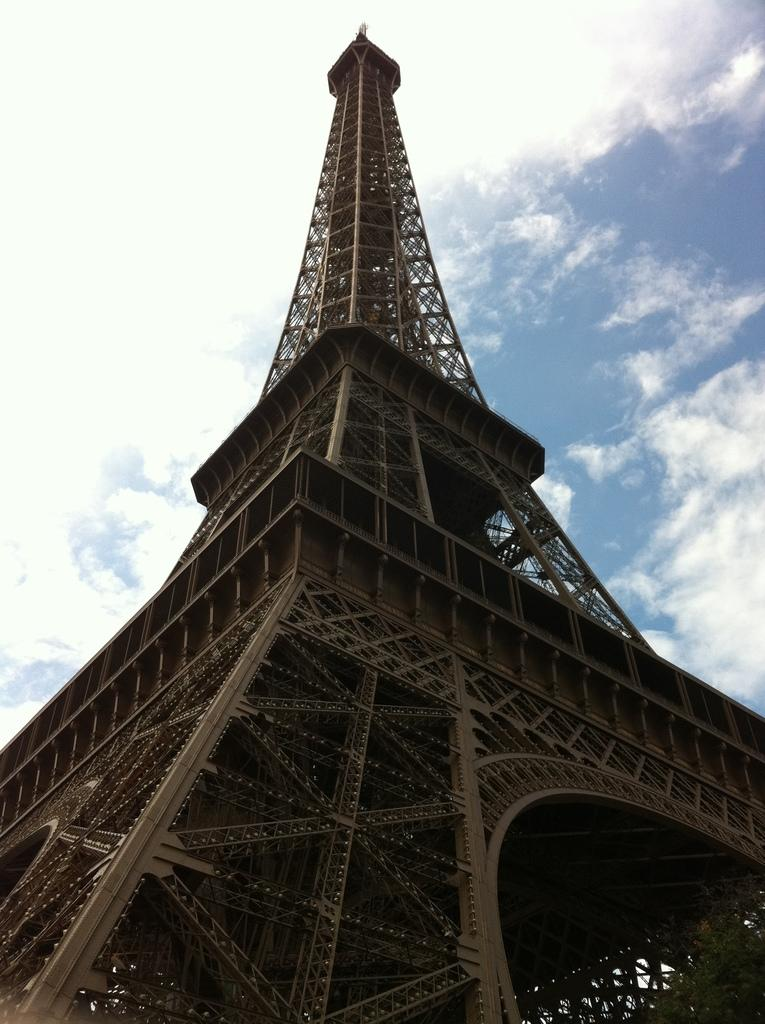What is the main structure visible in the image? There is a tower in the image. From where was the image captured? The image is captured from the bottom of the tower. What type of bead is used to decorate the notebook in the image? There is no notebook or bead present in the image; it only features a tower. 